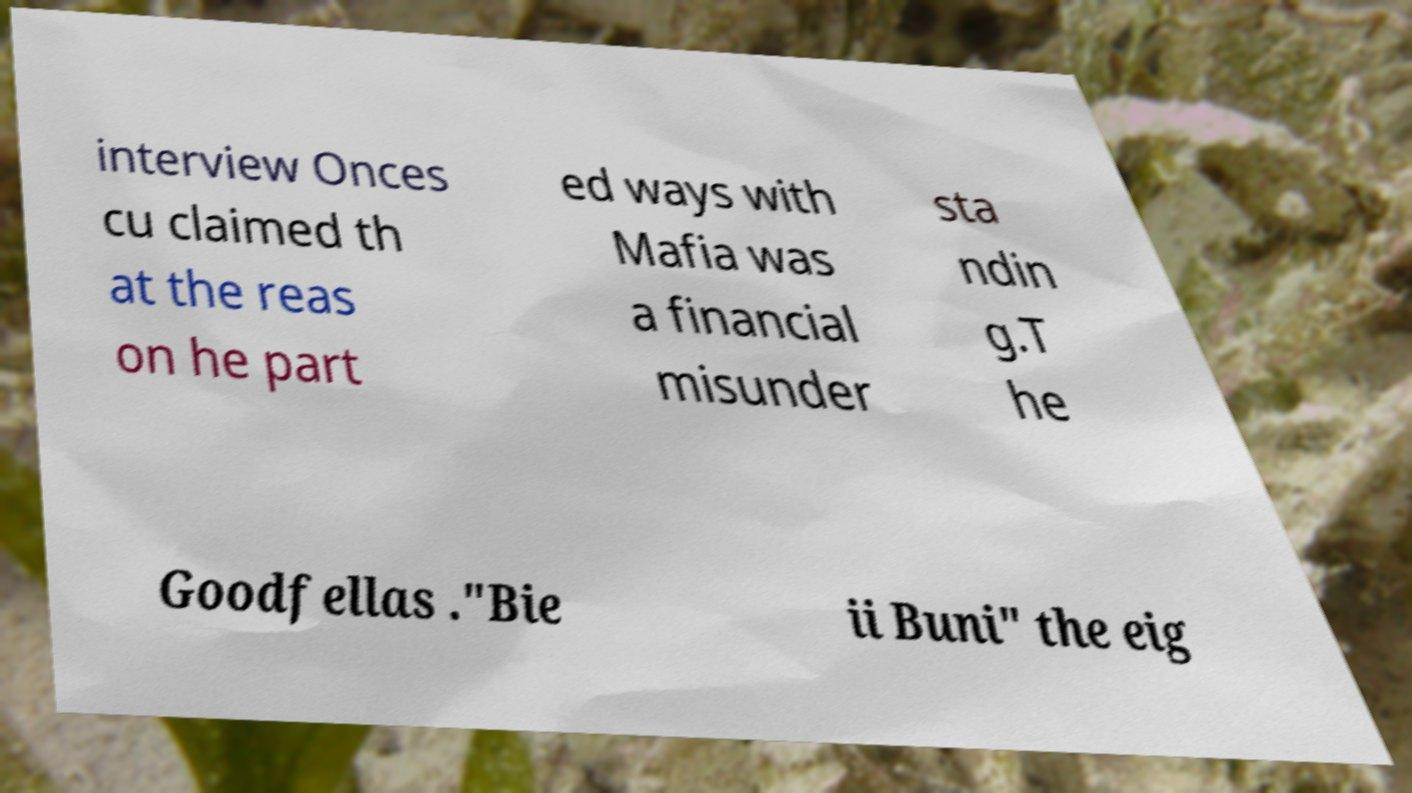Could you assist in decoding the text presented in this image and type it out clearly? interview Onces cu claimed th at the reas on he part ed ways with Mafia was a financial misunder sta ndin g.T he Goodfellas ."Bie ii Buni" the eig 